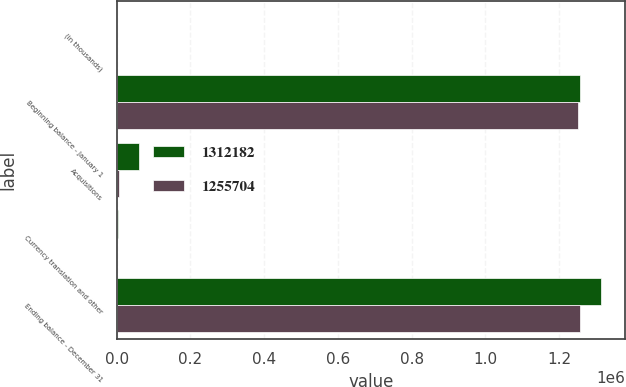Convert chart to OTSL. <chart><loc_0><loc_0><loc_500><loc_500><stacked_bar_chart><ecel><fcel>(in thousands)<fcel>Beginning balance - January 1<fcel>Acquisitions<fcel>Currency translation and other<fcel>Ending balance - December 31<nl><fcel>1.31218e+06<fcel>2014<fcel>1.2557e+06<fcel>61103<fcel>4625<fcel>1.31218e+06<nl><fcel>1.2557e+06<fcel>2013<fcel>1.25125e+06<fcel>5936<fcel>1479<fcel>1.2557e+06<nl></chart> 